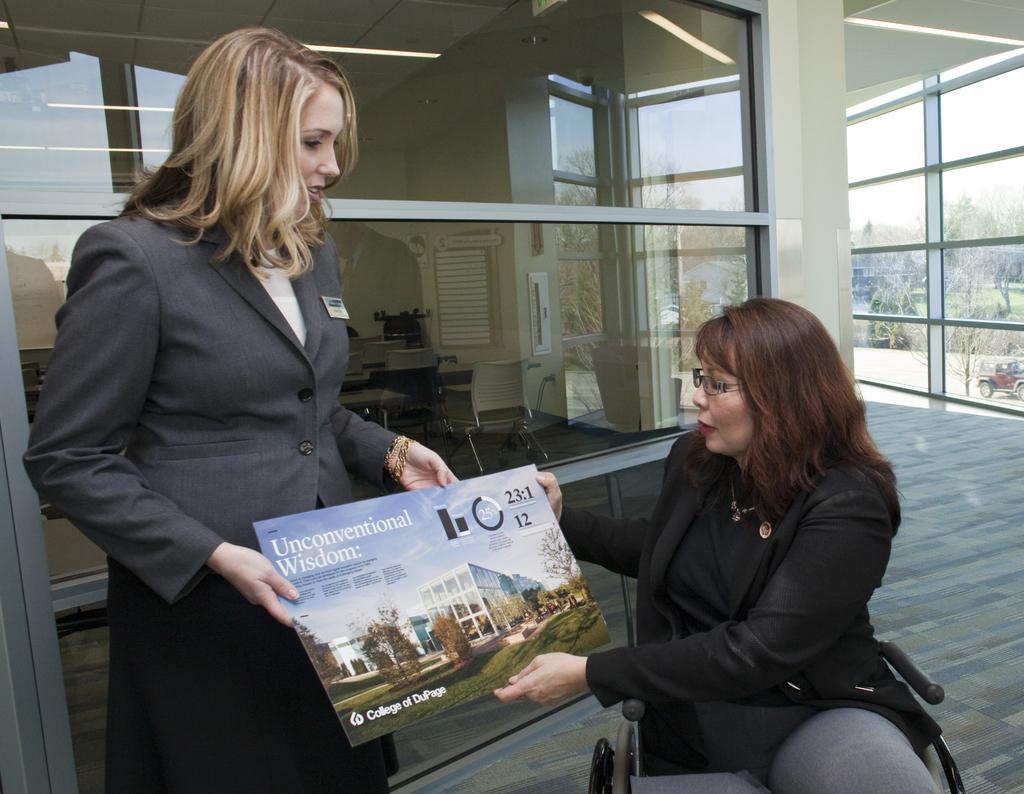Can you describe this image briefly? In this image we can see women and one of them is standing and the other is sitting on the chair by holding an advertisement in the hands. In the background there are chairs, tables, trees, buildings and sky. 